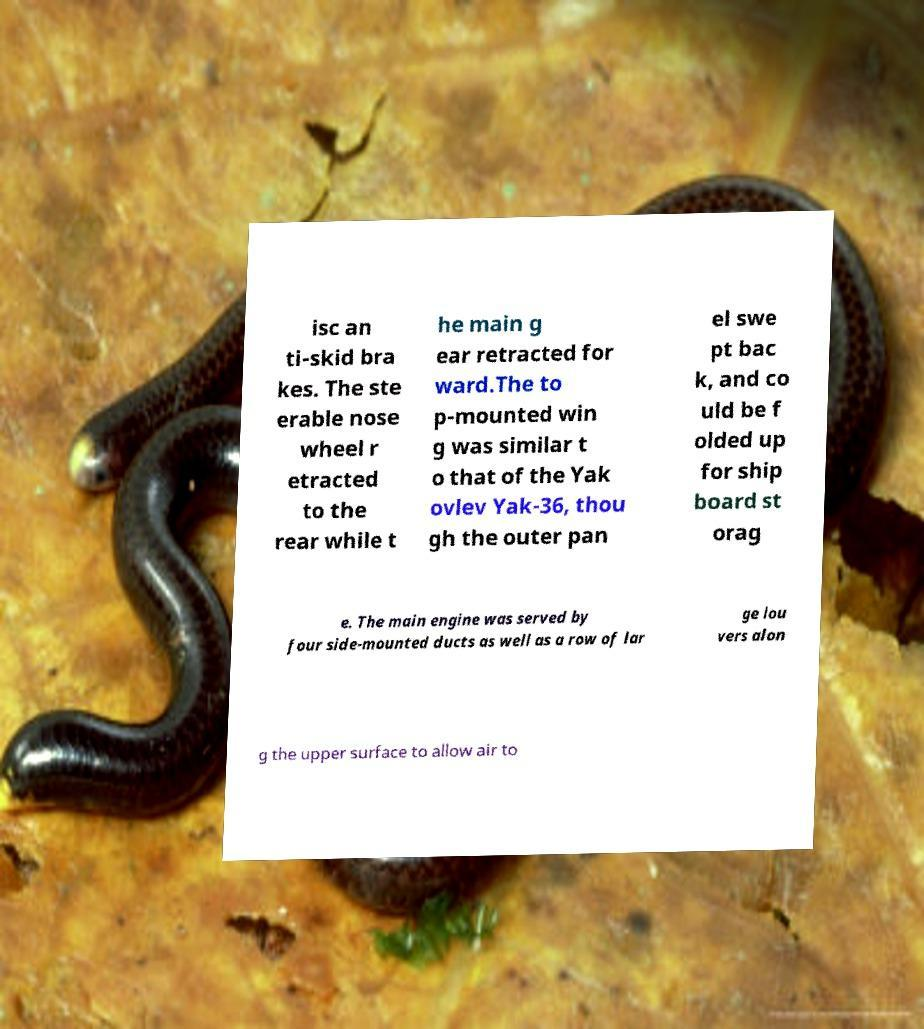Could you assist in decoding the text presented in this image and type it out clearly? isc an ti-skid bra kes. The ste erable nose wheel r etracted to the rear while t he main g ear retracted for ward.The to p-mounted win g was similar t o that of the Yak ovlev Yak-36, thou gh the outer pan el swe pt bac k, and co uld be f olded up for ship board st orag e. The main engine was served by four side-mounted ducts as well as a row of lar ge lou vers alon g the upper surface to allow air to 